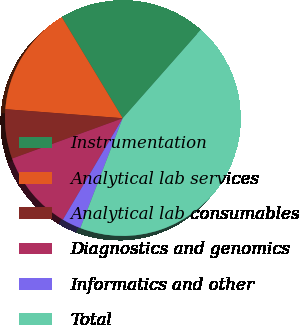<chart> <loc_0><loc_0><loc_500><loc_500><pie_chart><fcel>Instrumentation<fcel>Analytical lab services<fcel>Analytical lab consumables<fcel>Diagnostics and genomics<fcel>Informatics and other<fcel>Total<nl><fcel>20.15%<fcel>15.14%<fcel>6.79%<fcel>10.96%<fcel>2.62%<fcel>44.35%<nl></chart> 